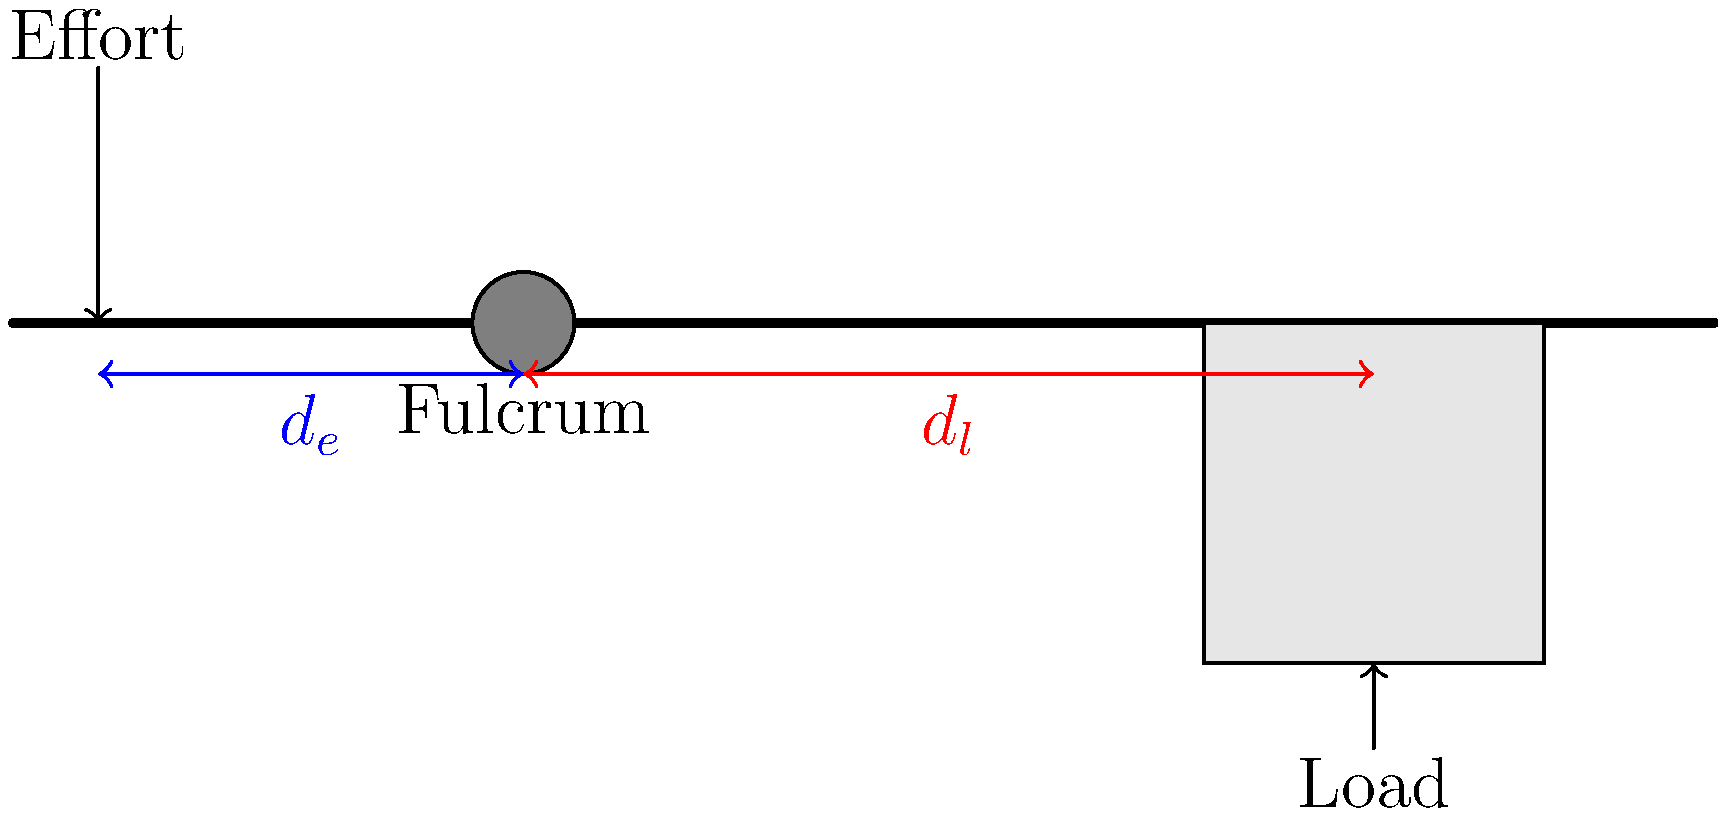In the diagram, a lever is used to move a large steel object. The distance from the effort to the fulcrum ($d_e$) is 2.5 meters, and the distance from the fulcrum to the load ($d_l$) is 5 meters. If the weight of the steel object is 1000 N, what is the minimum effort required to lift it, assuming the lever is weightless and there is no friction? To solve this problem, we'll use the principle of moments and the concept of mechanical advantage in levers. Here's a step-by-step explanation:

1) The principle of moments states that for a lever in equilibrium, the sum of clockwise moments equals the sum of anticlockwise moments about the fulcrum.

2) In this case:
   Effort × $d_e$ = Load × $d_l$

3) We know:
   $d_e$ = 2.5 m
   $d_l$ = 5 m
   Load = 1000 N

4) Let's call the Effort 'E'. We can now set up our equation:
   E × 2.5 = 1000 × 5

5) Simplify the right side:
   E × 2.5 = 5000

6) Divide both sides by 2.5:
   E = 5000 ÷ 2.5 = 2000

Therefore, the minimum effort required is 2000 N.

7) We can verify this using the concept of mechanical advantage (MA):
   MA = $\frac{d_e}{d_l}$ = $\frac{5}{2.5}$ = 2

   This means the lever multiplies the effort by 2, so an effort of 2000 N can indeed lift a load of 1000 N.
Answer: 2000 N 